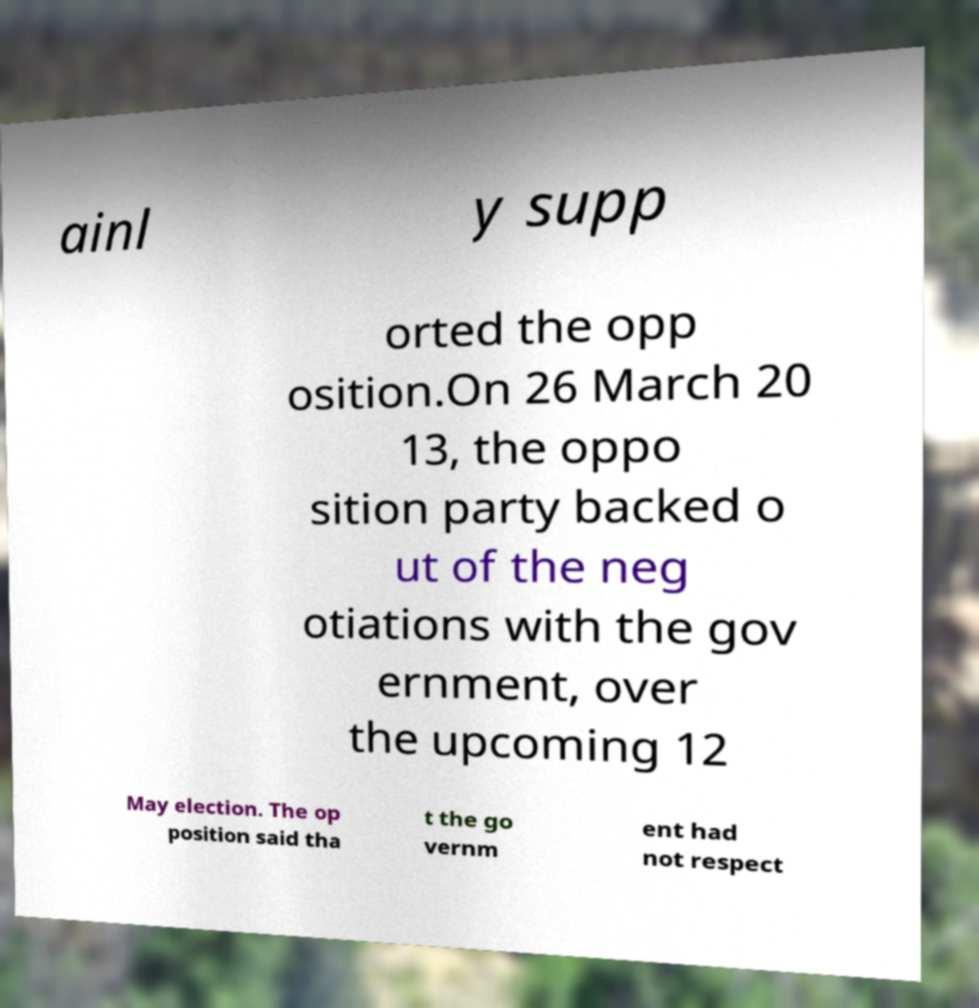Could you extract and type out the text from this image? ainl y supp orted the opp osition.On 26 March 20 13, the oppo sition party backed o ut of the neg otiations with the gov ernment, over the upcoming 12 May election. The op position said tha t the go vernm ent had not respect 